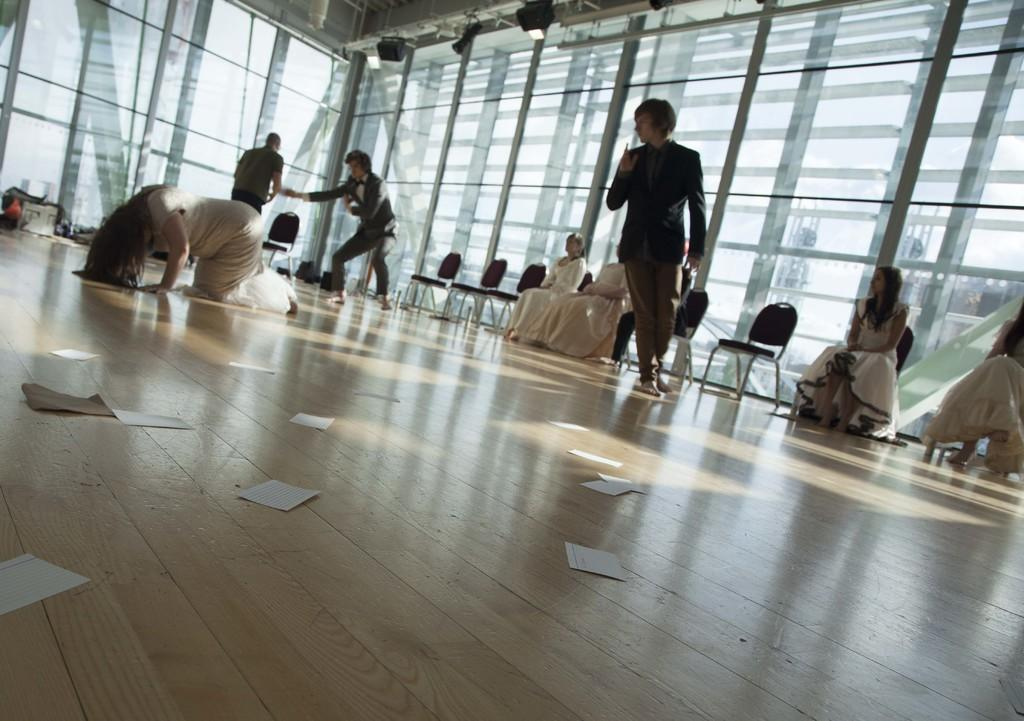How many persons are in the image? There are persons in the image. What type of furniture is present in the image? There are chairs in the image. What type of material is used for the windows in the image? There are glass windows in the image. What type of lighting is present in the image? There are lights in the image. What other objects can be seen in the image besides chairs and persons? There are other objects in the image. What can be seen at the bottom of the image? The floor is visible at the bottom of the image. What is on the floor in the image? There are papers on the floor. Can you tell me how many bottles of wine are on the table in the image? There is no table or wine bottles present in the image. 